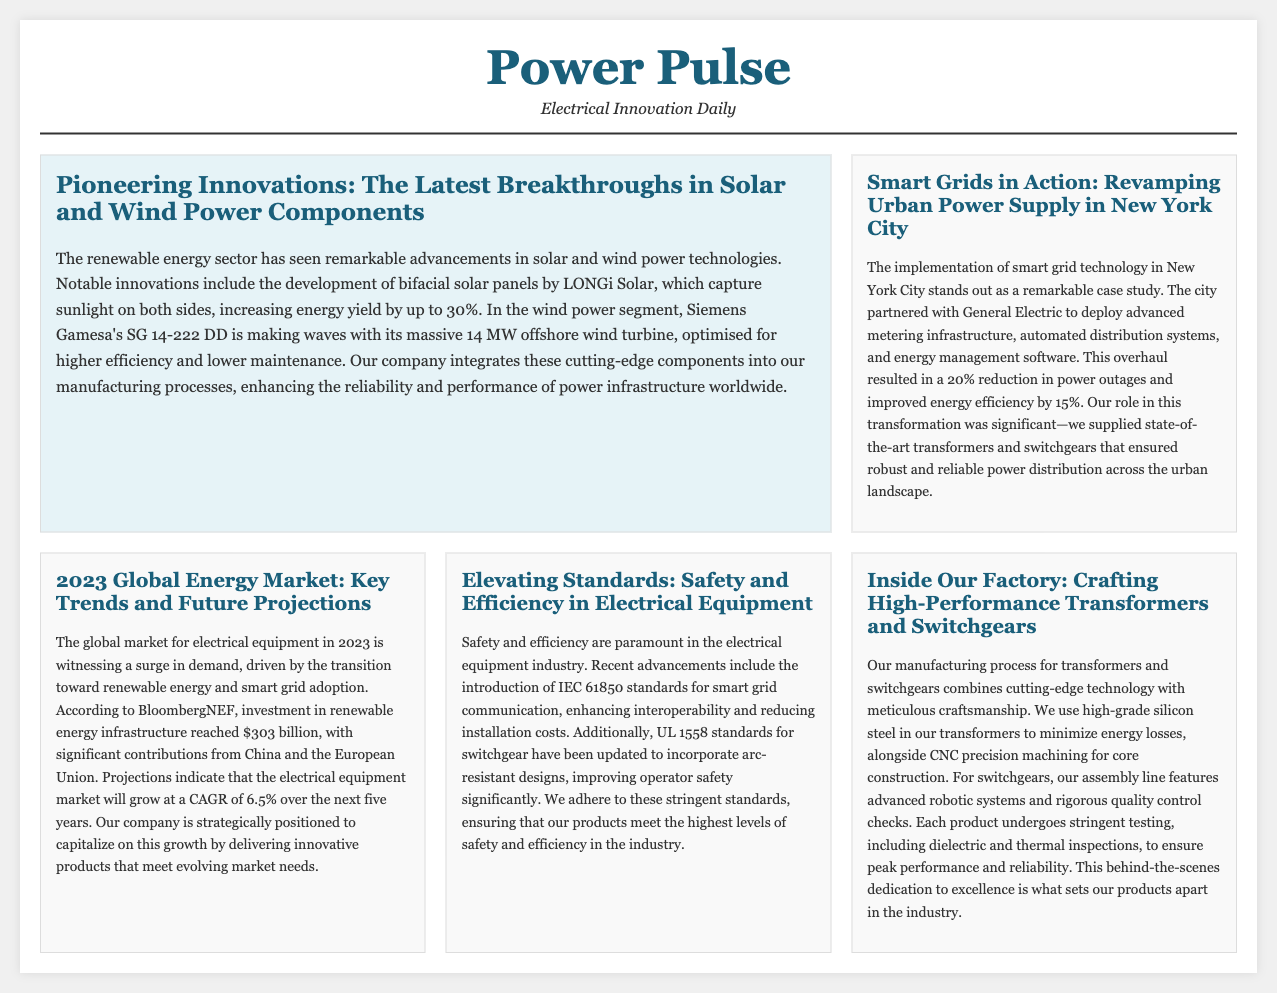What is the energy yield increase percentage for bifacial solar panels? The document states that bifacial solar panels can increase energy yield by up to 30%.
Answer: 30% What company collaborated with New York City on smart grid technology? The case study mentions that New York City partnered with General Electric for the implementation of smart grid technology.
Answer: General Electric What is the projected CAGR for the electrical equipment market over the next five years? The document indicates that the electrical equipment market is projected to grow at a CAGR of 6.5% over the next five years.
Answer: 6.5% What safety standard has been reintroduced for switchgear? The document specifies that UL 1558 standards for switchgear have been updated to incorporate arc-resistant designs.
Answer: UL 1558 What type of steel is used to minimize energy losses in transformers? The document mentions the use of high-grade silicon steel in transformers to minimize energy losses.
Answer: Silicon steel What is the reduction in power outages reported after smart grid implementation in NYC? The document notes that there was a 20% reduction in power outages in New York City after the smart grid technology implementation.
Answer: 20% Which company developed the SG 14-222 DD offshore wind turbine? The article states that Siemens Gamesa developed the SG 14-222 DD offshore wind turbine.
Answer: Siemens Gamesa What is one of the key components used in the manufacturing of switchgears? The manufacturing process for switchgears includes the use of advanced robotic systems as mentioned in the document.
Answer: Robotic systems What does the manufacturing process for transformers ensure through stringent testing? According to the document, each product undergoes stringent testing to ensure peak performance and reliability.
Answer: Peak performance and reliability 